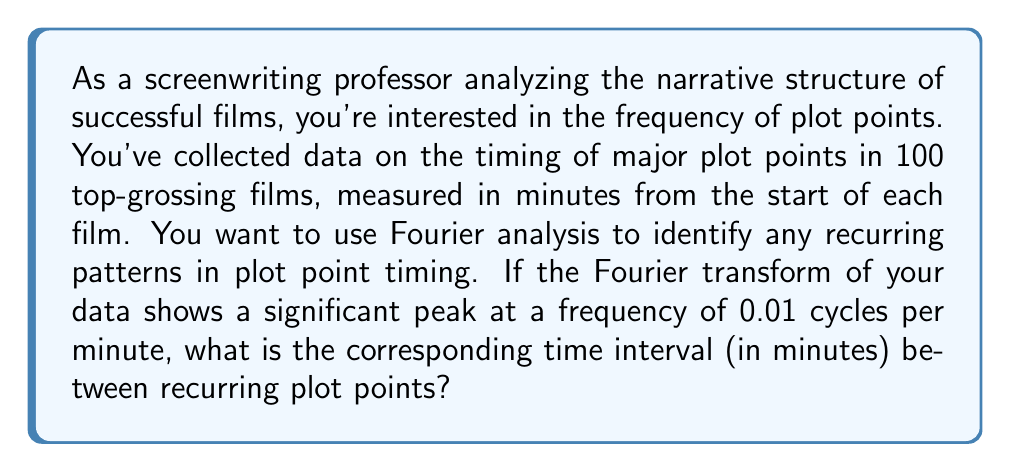Give your solution to this math problem. To solve this problem, we need to understand the relationship between frequency and time in Fourier analysis. The key steps are:

1) In Fourier analysis, frequency ($f$) is the number of cycles per unit of time. In this case, we're given a frequency of 0.01 cycles per minute.

2) The period ($T$) is the time for one complete cycle. It's the reciprocal of the frequency:

   $$T = \frac{1}{f}$$

3) Substituting our given frequency:

   $$T = \frac{1}{0.01} = 100$$

This means that the plot points recur every 100 minutes.

4) To interpret this result in the context of screenwriting:
   - A typical feature film is about 120 minutes long.
   - This 100-minute cycle suggests a major plot point occurs near the beginning and end of a typical film, with another significant point near the middle.
   - This aligns with common three-act structure in screenwriting, where major plot points often occur at the end of Act 1 (around 30 minutes in), at the midpoint (around 60 minutes in), and at the climax (around 90-100 minutes in).
Answer: The time interval between recurring plot points is 100 minutes. 